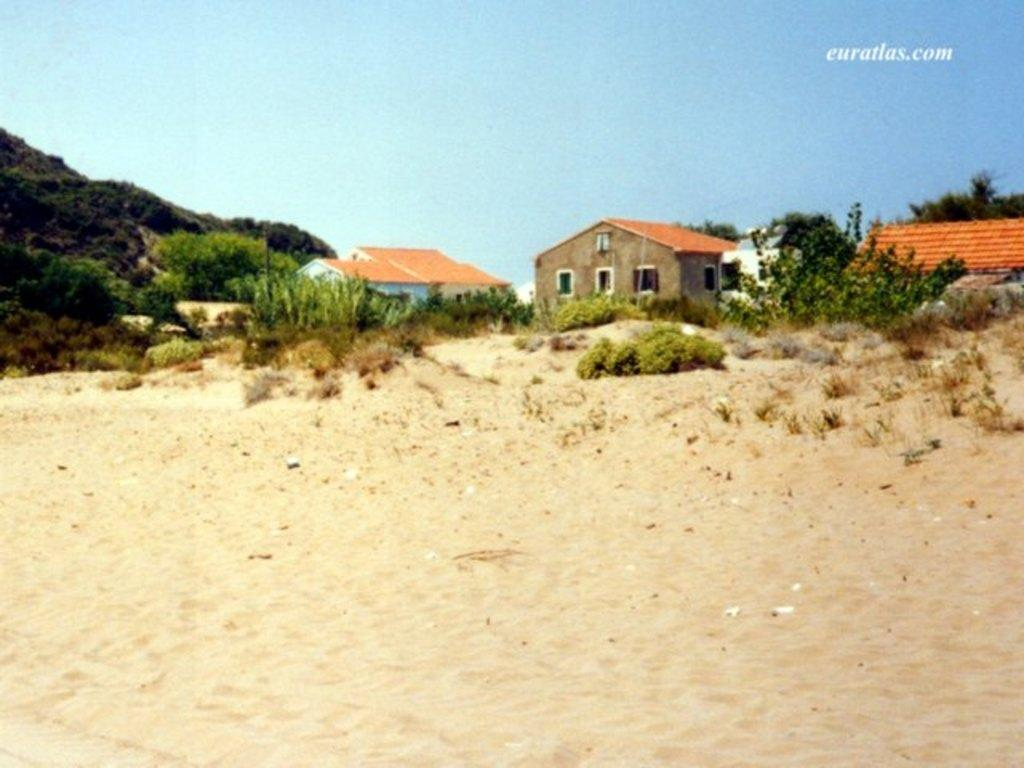What type of structures are located in the center of the image? There are houses in the center of the image. What type of vegetation can be seen in the image? There are trees, plants, and grass visible in the image. What is the ground made of in the image? There is sand at the bottom of the image. What is visible at the top of the image? The sky is visible at the top of the image. Is there any text present in the image? Yes, there is text in the image. How many visitors can be seen interacting with the kitty in the image? There is no kitty or visitor present in the image. What type of thing is being used to measure the height of the trees in the image? There is no measuring device or activity involving trees in the image. 